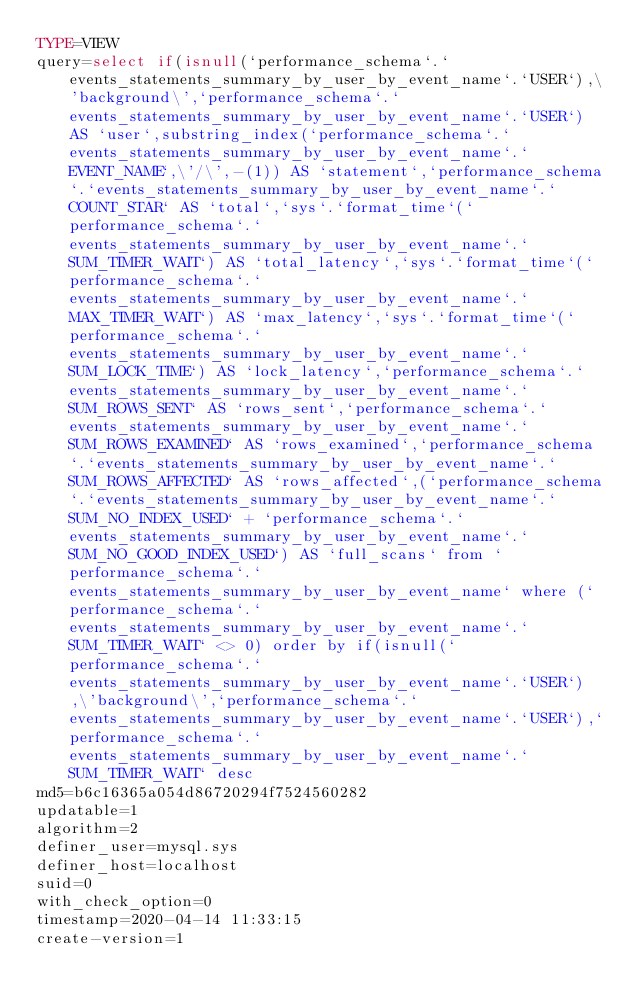Convert code to text. <code><loc_0><loc_0><loc_500><loc_500><_VisualBasic_>TYPE=VIEW
query=select if(isnull(`performance_schema`.`events_statements_summary_by_user_by_event_name`.`USER`),\'background\',`performance_schema`.`events_statements_summary_by_user_by_event_name`.`USER`) AS `user`,substring_index(`performance_schema`.`events_statements_summary_by_user_by_event_name`.`EVENT_NAME`,\'/\',-(1)) AS `statement`,`performance_schema`.`events_statements_summary_by_user_by_event_name`.`COUNT_STAR` AS `total`,`sys`.`format_time`(`performance_schema`.`events_statements_summary_by_user_by_event_name`.`SUM_TIMER_WAIT`) AS `total_latency`,`sys`.`format_time`(`performance_schema`.`events_statements_summary_by_user_by_event_name`.`MAX_TIMER_WAIT`) AS `max_latency`,`sys`.`format_time`(`performance_schema`.`events_statements_summary_by_user_by_event_name`.`SUM_LOCK_TIME`) AS `lock_latency`,`performance_schema`.`events_statements_summary_by_user_by_event_name`.`SUM_ROWS_SENT` AS `rows_sent`,`performance_schema`.`events_statements_summary_by_user_by_event_name`.`SUM_ROWS_EXAMINED` AS `rows_examined`,`performance_schema`.`events_statements_summary_by_user_by_event_name`.`SUM_ROWS_AFFECTED` AS `rows_affected`,(`performance_schema`.`events_statements_summary_by_user_by_event_name`.`SUM_NO_INDEX_USED` + `performance_schema`.`events_statements_summary_by_user_by_event_name`.`SUM_NO_GOOD_INDEX_USED`) AS `full_scans` from `performance_schema`.`events_statements_summary_by_user_by_event_name` where (`performance_schema`.`events_statements_summary_by_user_by_event_name`.`SUM_TIMER_WAIT` <> 0) order by if(isnull(`performance_schema`.`events_statements_summary_by_user_by_event_name`.`USER`),\'background\',`performance_schema`.`events_statements_summary_by_user_by_event_name`.`USER`),`performance_schema`.`events_statements_summary_by_user_by_event_name`.`SUM_TIMER_WAIT` desc
md5=b6c16365a054d86720294f7524560282
updatable=1
algorithm=2
definer_user=mysql.sys
definer_host=localhost
suid=0
with_check_option=0
timestamp=2020-04-14 11:33:15
create-version=1</code> 